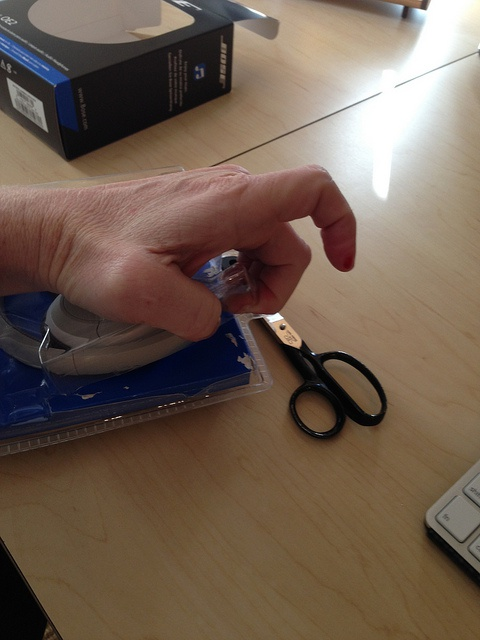Describe the objects in this image and their specific colors. I can see people in darkgray, maroon, gray, brown, and black tones, scissors in darkgray, black, brown, gray, and maroon tones, and keyboard in darkgray, gray, and black tones in this image. 